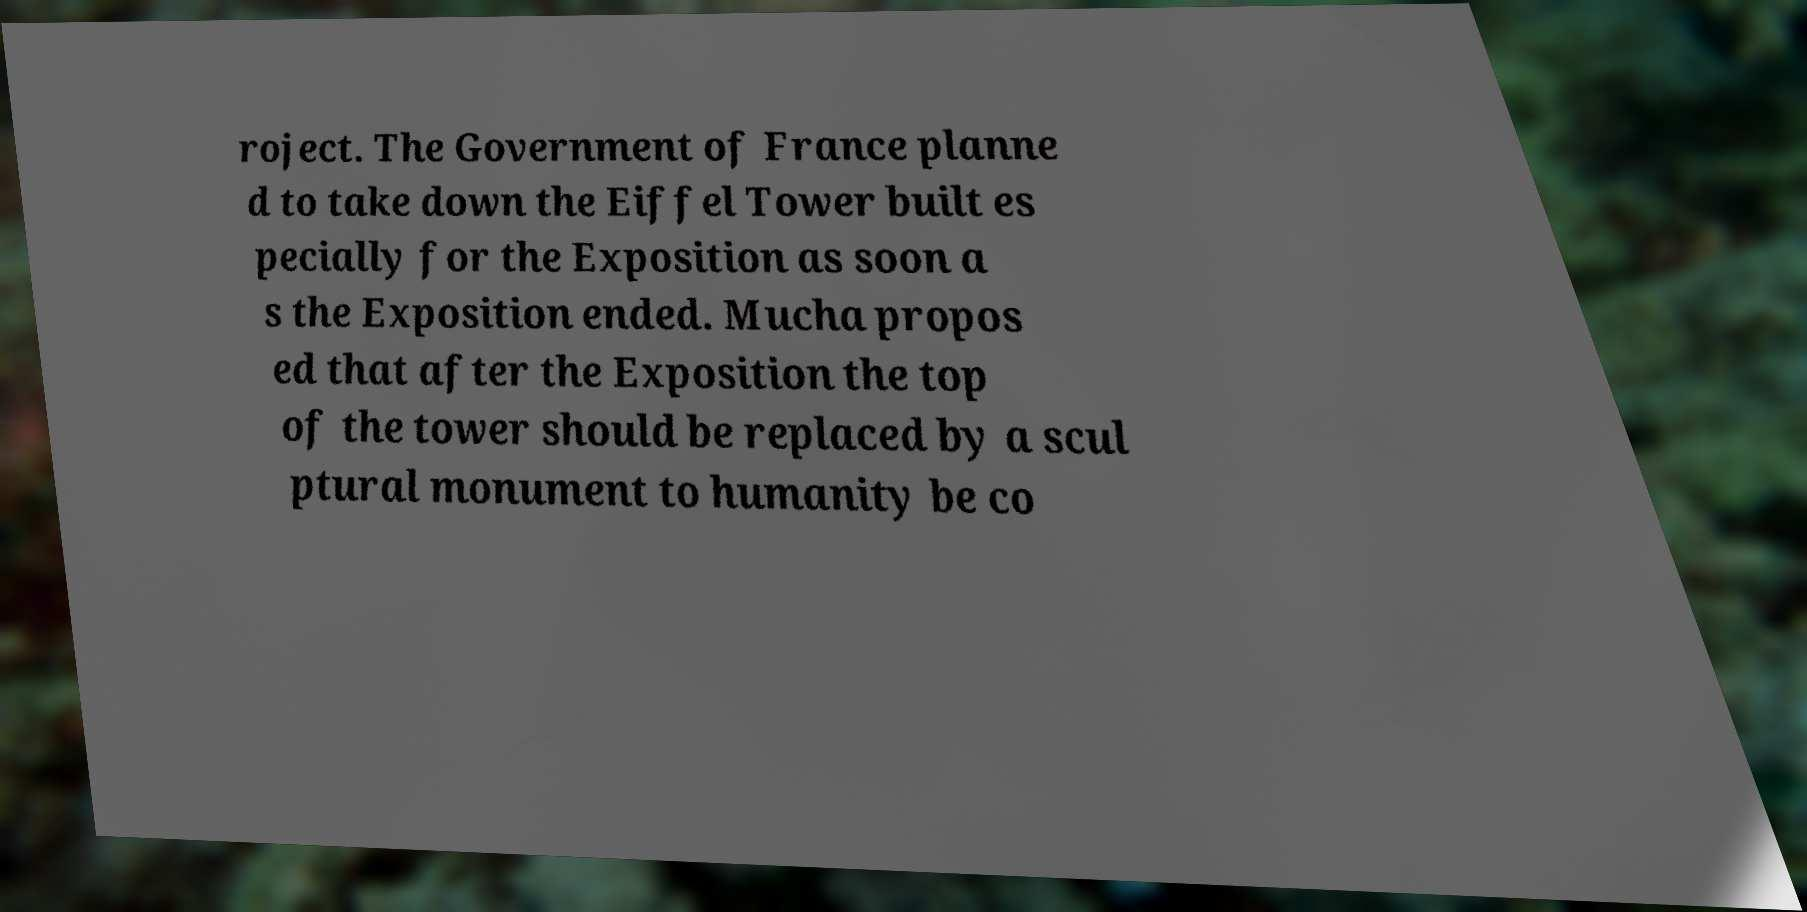Please identify and transcribe the text found in this image. roject. The Government of France planne d to take down the Eiffel Tower built es pecially for the Exposition as soon a s the Exposition ended. Mucha propos ed that after the Exposition the top of the tower should be replaced by a scul ptural monument to humanity be co 